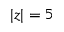Convert formula to latex. <formula><loc_0><loc_0><loc_500><loc_500>| z | = 5</formula> 